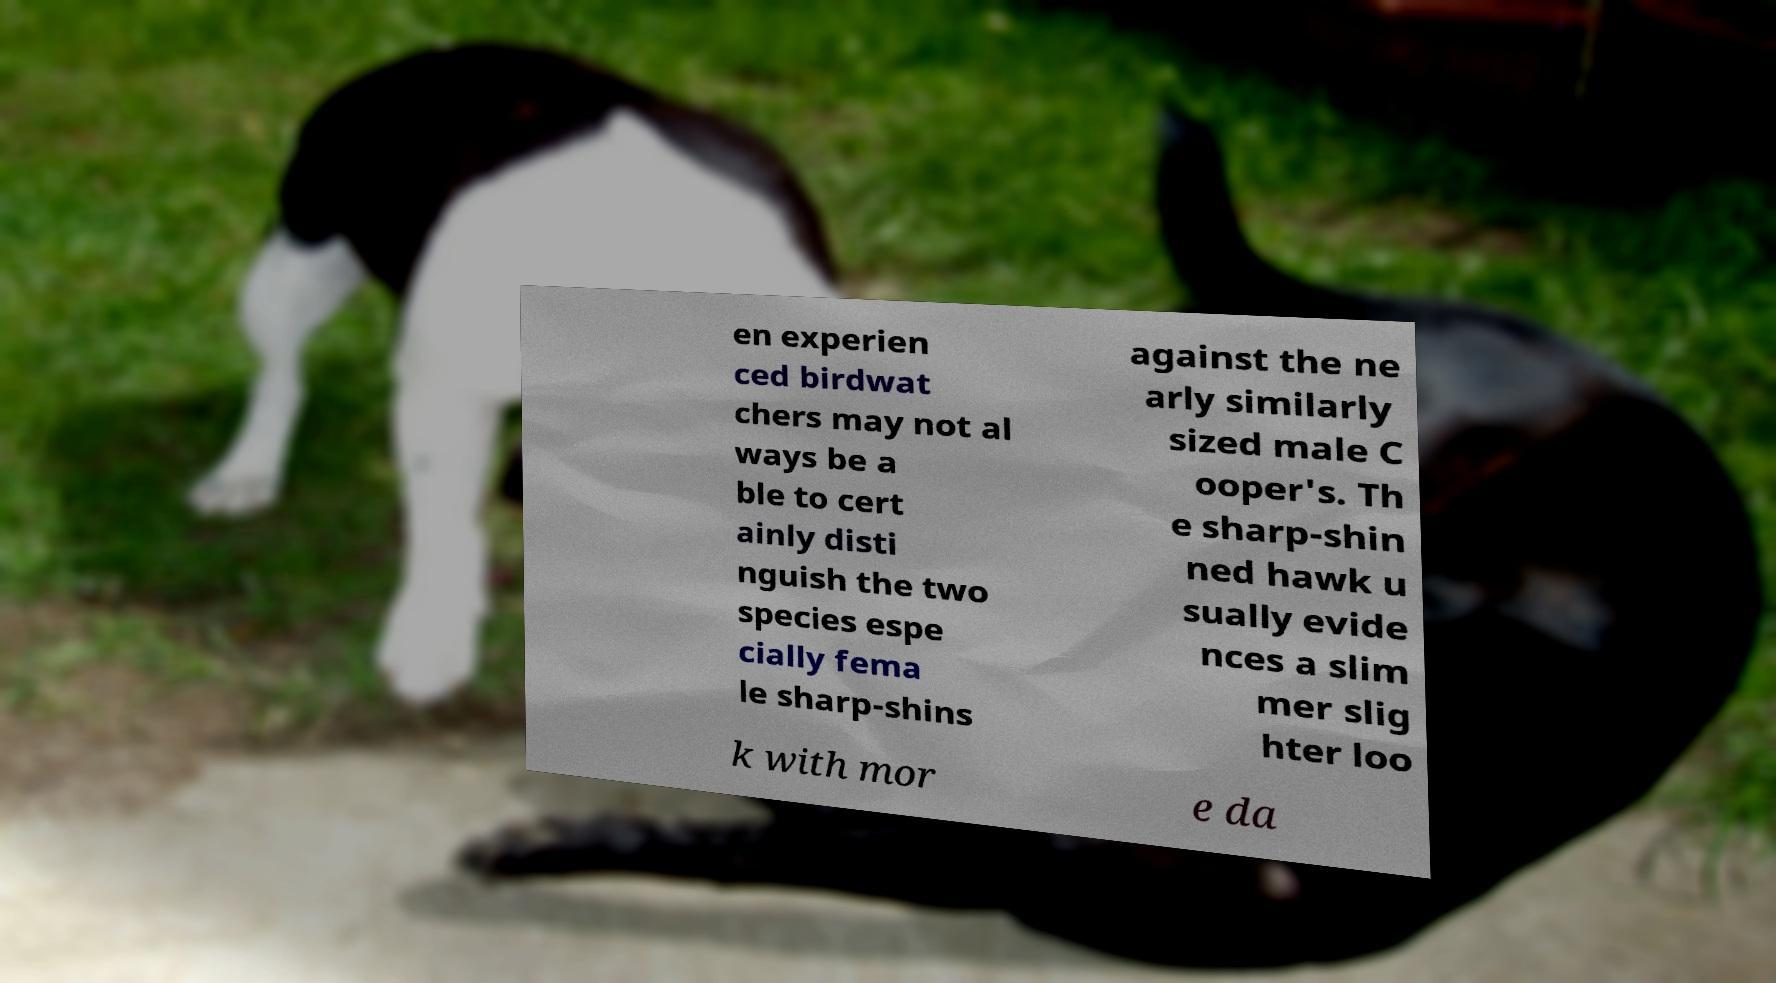I need the written content from this picture converted into text. Can you do that? en experien ced birdwat chers may not al ways be a ble to cert ainly disti nguish the two species espe cially fema le sharp-shins against the ne arly similarly sized male C ooper's. Th e sharp-shin ned hawk u sually evide nces a slim mer slig hter loo k with mor e da 